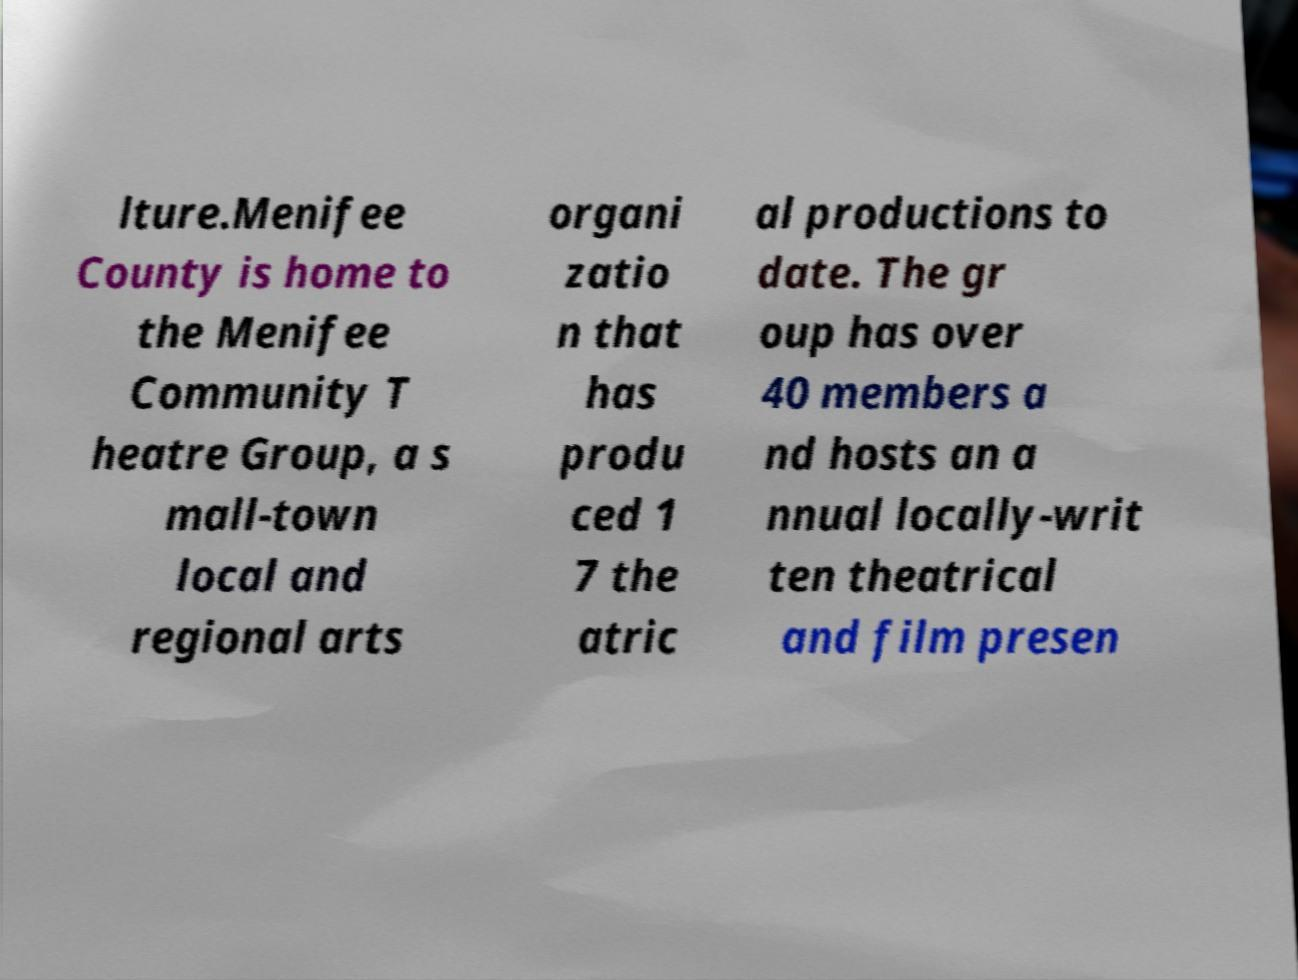Can you read and provide the text displayed in the image?This photo seems to have some interesting text. Can you extract and type it out for me? lture.Menifee County is home to the Menifee Community T heatre Group, a s mall-town local and regional arts organi zatio n that has produ ced 1 7 the atric al productions to date. The gr oup has over 40 members a nd hosts an a nnual locally-writ ten theatrical and film presen 